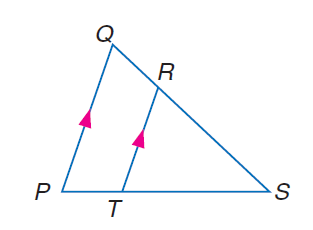Answer the mathemtical geometry problem and directly provide the correct option letter.
Question: If P T = y - 3, P S = y + 2, R S = 12, and Q S = 16 solve for y.
Choices: A: \frac { 3 } { 14 } B: \frac { 2 } { 3 } C: \frac { 3 } { 2 } D: \frac { 14 } { 3 } D 